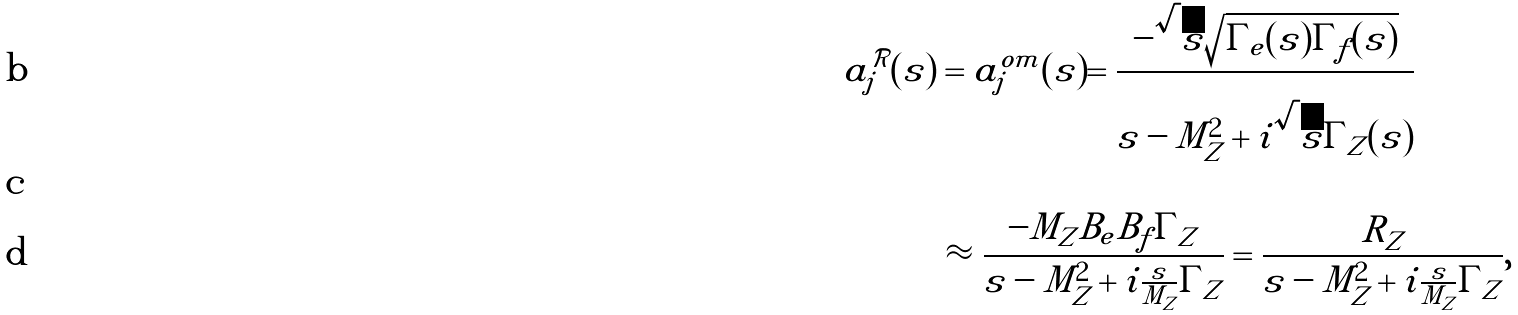<formula> <loc_0><loc_0><loc_500><loc_500>a _ { j } ^ { \mathcal { R } } ( s ) & = a _ { j } ^ { o m } ( s ) = \frac { - \sqrt { s } \sqrt { \Gamma _ { e } ( s ) \Gamma _ { f } ( s ) } } { s - M _ { Z } ^ { 2 } + i \sqrt { s } \Gamma _ { Z } ( s ) } \quad \\ \\ & \approx \frac { - M _ { Z } B _ { e } B _ { f } \Gamma _ { Z } } { s - M _ { Z } ^ { 2 } + i \frac { s } { M _ { Z } } \Gamma _ { Z } } = \frac { R _ { Z } } { s - M _ { Z } ^ { 2 } + i \frac { s } { M _ { Z } } \Gamma _ { Z } } ,</formula> 